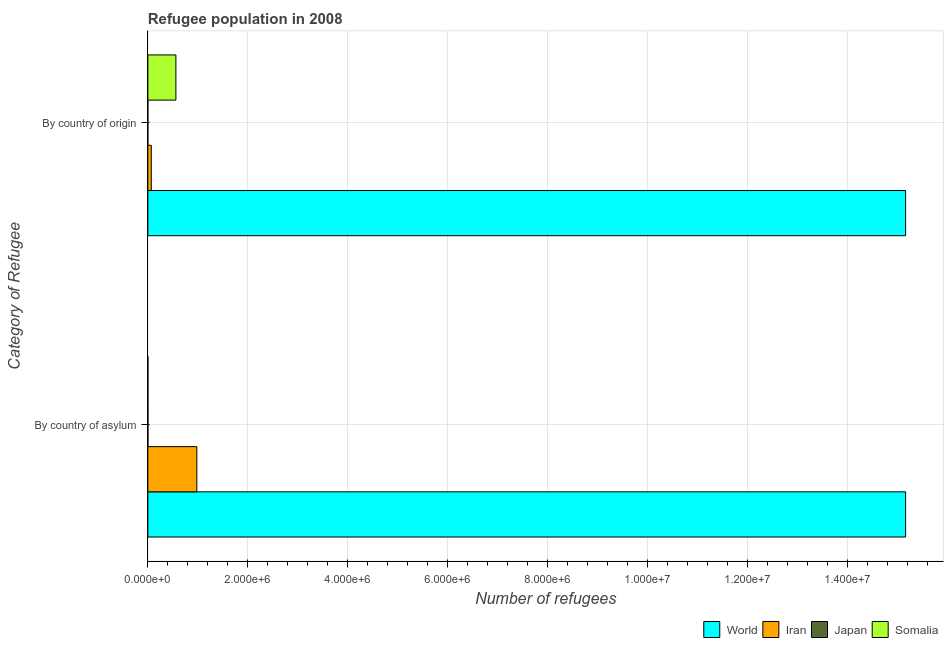How many different coloured bars are there?
Make the answer very short. 4. How many groups of bars are there?
Ensure brevity in your answer.  2. How many bars are there on the 1st tick from the bottom?
Your answer should be compact. 4. What is the label of the 1st group of bars from the top?
Offer a very short reply. By country of origin. What is the number of refugees by country of asylum in Japan?
Your response must be concise. 2019. Across all countries, what is the maximum number of refugees by country of asylum?
Give a very brief answer. 1.52e+07. Across all countries, what is the minimum number of refugees by country of asylum?
Ensure brevity in your answer.  1842. In which country was the number of refugees by country of origin maximum?
Give a very brief answer. World. In which country was the number of refugees by country of asylum minimum?
Offer a terse response. Somalia. What is the total number of refugees by country of asylum in the graph?
Offer a terse response. 1.61e+07. What is the difference between the number of refugees by country of asylum in Iran and that in Somalia?
Make the answer very short. 9.78e+05. What is the difference between the number of refugees by country of asylum in World and the number of refugees by country of origin in Iran?
Offer a very short reply. 1.51e+07. What is the average number of refugees by country of asylum per country?
Keep it short and to the point. 4.04e+06. What is the difference between the number of refugees by country of origin and number of refugees by country of asylum in Somalia?
Your answer should be very brief. 5.59e+05. What is the ratio of the number of refugees by country of origin in Somalia to that in World?
Ensure brevity in your answer.  0.04. Is the number of refugees by country of origin in Iran less than that in Japan?
Give a very brief answer. No. In how many countries, is the number of refugees by country of asylum greater than the average number of refugees by country of asylum taken over all countries?
Provide a short and direct response. 1. What does the 3rd bar from the top in By country of origin represents?
Your answer should be very brief. Iran. What does the 1st bar from the bottom in By country of asylum represents?
Your response must be concise. World. Are all the bars in the graph horizontal?
Your answer should be very brief. Yes. How many countries are there in the graph?
Provide a short and direct response. 4. Are the values on the major ticks of X-axis written in scientific E-notation?
Your response must be concise. Yes. Where does the legend appear in the graph?
Your answer should be compact. Bottom right. How are the legend labels stacked?
Ensure brevity in your answer.  Horizontal. What is the title of the graph?
Ensure brevity in your answer.  Refugee population in 2008. Does "Rwanda" appear as one of the legend labels in the graph?
Your response must be concise. No. What is the label or title of the X-axis?
Ensure brevity in your answer.  Number of refugees. What is the label or title of the Y-axis?
Your response must be concise. Category of Refugee. What is the Number of refugees of World in By country of asylum?
Your answer should be compact. 1.52e+07. What is the Number of refugees in Iran in By country of asylum?
Ensure brevity in your answer.  9.80e+05. What is the Number of refugees in Japan in By country of asylum?
Provide a short and direct response. 2019. What is the Number of refugees in Somalia in By country of asylum?
Offer a terse response. 1842. What is the Number of refugees in World in By country of origin?
Your answer should be compact. 1.52e+07. What is the Number of refugees of Iran in By country of origin?
Keep it short and to the point. 6.91e+04. What is the Number of refugees in Japan in By country of origin?
Provide a short and direct response. 185. What is the Number of refugees in Somalia in By country of origin?
Make the answer very short. 5.61e+05. Across all Category of Refugee, what is the maximum Number of refugees in World?
Keep it short and to the point. 1.52e+07. Across all Category of Refugee, what is the maximum Number of refugees in Iran?
Keep it short and to the point. 9.80e+05. Across all Category of Refugee, what is the maximum Number of refugees of Japan?
Your response must be concise. 2019. Across all Category of Refugee, what is the maximum Number of refugees of Somalia?
Provide a short and direct response. 5.61e+05. Across all Category of Refugee, what is the minimum Number of refugees of World?
Ensure brevity in your answer.  1.52e+07. Across all Category of Refugee, what is the minimum Number of refugees in Iran?
Your answer should be very brief. 6.91e+04. Across all Category of Refugee, what is the minimum Number of refugees in Japan?
Your answer should be compact. 185. Across all Category of Refugee, what is the minimum Number of refugees of Somalia?
Ensure brevity in your answer.  1842. What is the total Number of refugees of World in the graph?
Your answer should be very brief. 3.03e+07. What is the total Number of refugees of Iran in the graph?
Keep it short and to the point. 1.05e+06. What is the total Number of refugees of Japan in the graph?
Keep it short and to the point. 2204. What is the total Number of refugees in Somalia in the graph?
Offer a very short reply. 5.63e+05. What is the difference between the Number of refugees of World in By country of asylum and that in By country of origin?
Offer a terse response. -1. What is the difference between the Number of refugees of Iran in By country of asylum and that in By country of origin?
Ensure brevity in your answer.  9.11e+05. What is the difference between the Number of refugees in Japan in By country of asylum and that in By country of origin?
Keep it short and to the point. 1834. What is the difference between the Number of refugees in Somalia in By country of asylum and that in By country of origin?
Your response must be concise. -5.59e+05. What is the difference between the Number of refugees in World in By country of asylum and the Number of refugees in Iran in By country of origin?
Keep it short and to the point. 1.51e+07. What is the difference between the Number of refugees of World in By country of asylum and the Number of refugees of Japan in By country of origin?
Offer a very short reply. 1.52e+07. What is the difference between the Number of refugees of World in By country of asylum and the Number of refugees of Somalia in By country of origin?
Your response must be concise. 1.46e+07. What is the difference between the Number of refugees of Iran in By country of asylum and the Number of refugees of Japan in By country of origin?
Provide a short and direct response. 9.80e+05. What is the difference between the Number of refugees in Iran in By country of asylum and the Number of refugees in Somalia in By country of origin?
Offer a terse response. 4.19e+05. What is the difference between the Number of refugees in Japan in By country of asylum and the Number of refugees in Somalia in By country of origin?
Ensure brevity in your answer.  -5.59e+05. What is the average Number of refugees in World per Category of Refugee?
Provide a short and direct response. 1.52e+07. What is the average Number of refugees in Iran per Category of Refugee?
Ensure brevity in your answer.  5.25e+05. What is the average Number of refugees of Japan per Category of Refugee?
Ensure brevity in your answer.  1102. What is the average Number of refugees of Somalia per Category of Refugee?
Provide a succinct answer. 2.81e+05. What is the difference between the Number of refugees of World and Number of refugees of Iran in By country of asylum?
Offer a very short reply. 1.42e+07. What is the difference between the Number of refugees in World and Number of refugees in Japan in By country of asylum?
Provide a short and direct response. 1.52e+07. What is the difference between the Number of refugees of World and Number of refugees of Somalia in By country of asylum?
Ensure brevity in your answer.  1.52e+07. What is the difference between the Number of refugees in Iran and Number of refugees in Japan in By country of asylum?
Your answer should be compact. 9.78e+05. What is the difference between the Number of refugees in Iran and Number of refugees in Somalia in By country of asylum?
Provide a succinct answer. 9.78e+05. What is the difference between the Number of refugees of Japan and Number of refugees of Somalia in By country of asylum?
Offer a terse response. 177. What is the difference between the Number of refugees in World and Number of refugees in Iran in By country of origin?
Your answer should be very brief. 1.51e+07. What is the difference between the Number of refugees in World and Number of refugees in Japan in By country of origin?
Make the answer very short. 1.52e+07. What is the difference between the Number of refugees of World and Number of refugees of Somalia in By country of origin?
Offer a very short reply. 1.46e+07. What is the difference between the Number of refugees in Iran and Number of refugees in Japan in By country of origin?
Your answer should be compact. 6.89e+04. What is the difference between the Number of refugees of Iran and Number of refugees of Somalia in By country of origin?
Offer a terse response. -4.92e+05. What is the difference between the Number of refugees in Japan and Number of refugees in Somalia in By country of origin?
Offer a very short reply. -5.61e+05. What is the ratio of the Number of refugees of Iran in By country of asylum to that in By country of origin?
Offer a terse response. 14.19. What is the ratio of the Number of refugees of Japan in By country of asylum to that in By country of origin?
Offer a terse response. 10.91. What is the ratio of the Number of refugees in Somalia in By country of asylum to that in By country of origin?
Your response must be concise. 0. What is the difference between the highest and the second highest Number of refugees in World?
Make the answer very short. 1. What is the difference between the highest and the second highest Number of refugees in Iran?
Your answer should be compact. 9.11e+05. What is the difference between the highest and the second highest Number of refugees in Japan?
Give a very brief answer. 1834. What is the difference between the highest and the second highest Number of refugees in Somalia?
Your response must be concise. 5.59e+05. What is the difference between the highest and the lowest Number of refugees in World?
Offer a terse response. 1. What is the difference between the highest and the lowest Number of refugees in Iran?
Ensure brevity in your answer.  9.11e+05. What is the difference between the highest and the lowest Number of refugees in Japan?
Keep it short and to the point. 1834. What is the difference between the highest and the lowest Number of refugees of Somalia?
Your answer should be very brief. 5.59e+05. 